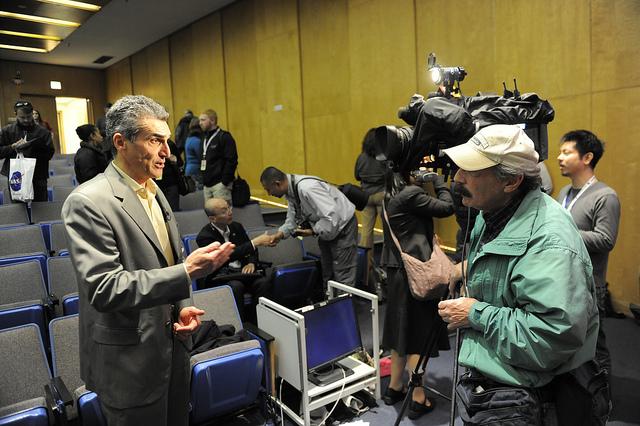Is the room crowded?
Answer briefly. Yes. What color is the man's hat?
Short answer required. Yellow. What is the man sitting on?
Keep it brief. Chair. What is the person wearing a suit is doing?
Give a very brief answer. Talking. 